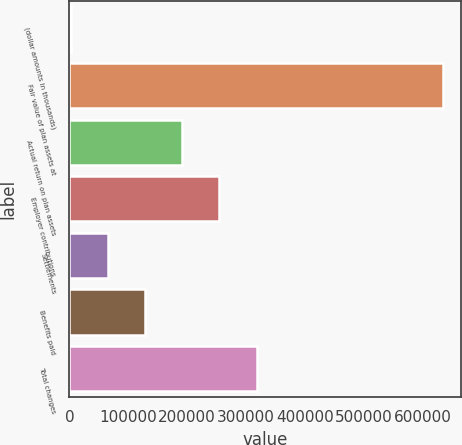Convert chart. <chart><loc_0><loc_0><loc_500><loc_500><bar_chart><fcel>(dollar amounts in thousands)<fcel>Fair value of plan assets at<fcel>Actual return on plan assets<fcel>Employer contributions<fcel>Settlements<fcel>Benefits paid<fcel>Total changes<nl><fcel>2012<fcel>633617<fcel>191494<fcel>254654<fcel>65172.5<fcel>128333<fcel>317814<nl></chart> 